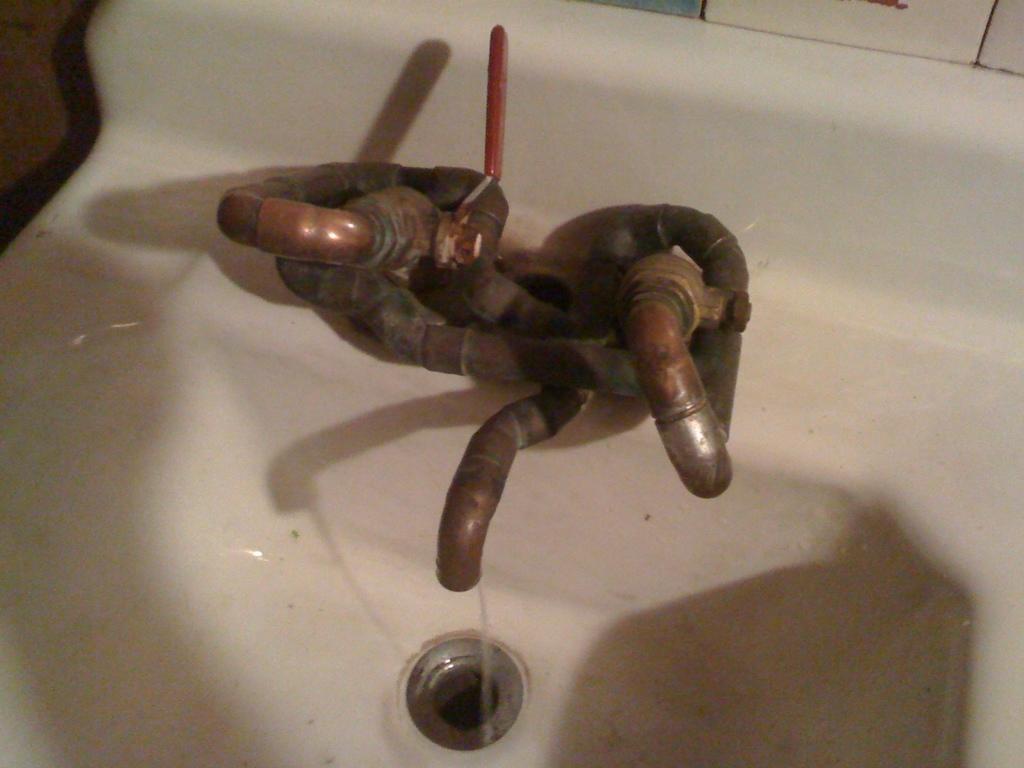Describe this image in one or two sentences. In this picture I can see a white color wash basin which has taps on it. Here I can see water. 